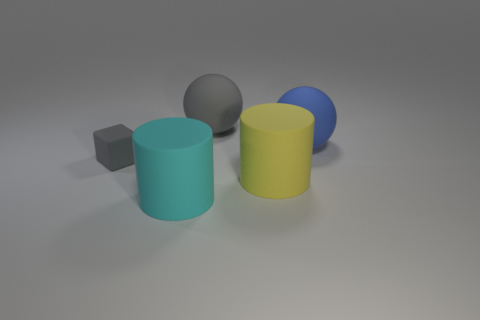Add 2 gray things. How many objects exist? 7 Subtract all spheres. How many objects are left? 3 Subtract all yellow blocks. Subtract all large cyan cylinders. How many objects are left? 4 Add 3 gray spheres. How many gray spheres are left? 4 Add 5 matte cubes. How many matte cubes exist? 6 Subtract 0 purple balls. How many objects are left? 5 